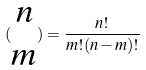Convert formula to latex. <formula><loc_0><loc_0><loc_500><loc_500>( \begin{matrix} n \\ m \end{matrix} ) = \frac { n ! } { m ! ( n - m ) ! }</formula> 